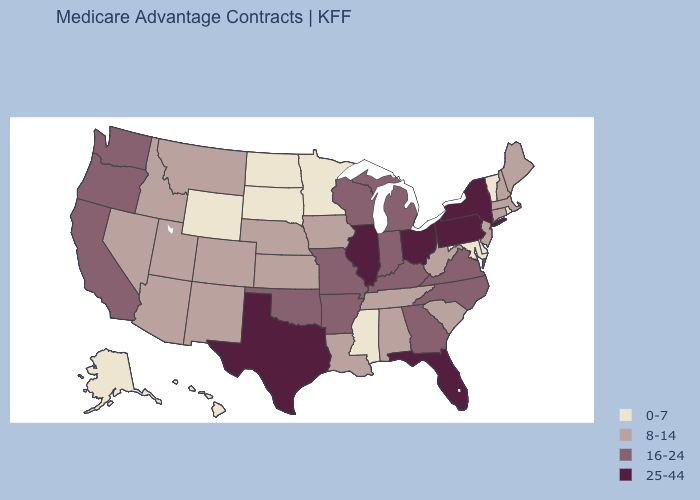What is the value of Mississippi?
Short answer required. 0-7. Which states have the lowest value in the USA?
Keep it brief. Alaska, Delaware, Hawaii, Maryland, Minnesota, Mississippi, North Dakota, Rhode Island, South Dakota, Vermont, Wyoming. What is the value of Montana?
Short answer required. 8-14. Name the states that have a value in the range 8-14?
Answer briefly. Alabama, Arizona, Colorado, Connecticut, Iowa, Idaho, Kansas, Louisiana, Massachusetts, Maine, Montana, Nebraska, New Hampshire, New Jersey, New Mexico, Nevada, South Carolina, Tennessee, Utah, West Virginia. Name the states that have a value in the range 16-24?
Answer briefly. Arkansas, California, Georgia, Indiana, Kentucky, Michigan, Missouri, North Carolina, Oklahoma, Oregon, Virginia, Washington, Wisconsin. Which states have the lowest value in the USA?
Be succinct. Alaska, Delaware, Hawaii, Maryland, Minnesota, Mississippi, North Dakota, Rhode Island, South Dakota, Vermont, Wyoming. What is the value of Missouri?
Short answer required. 16-24. Which states have the lowest value in the USA?
Concise answer only. Alaska, Delaware, Hawaii, Maryland, Minnesota, Mississippi, North Dakota, Rhode Island, South Dakota, Vermont, Wyoming. Name the states that have a value in the range 25-44?
Give a very brief answer. Florida, Illinois, New York, Ohio, Pennsylvania, Texas. How many symbols are there in the legend?
Quick response, please. 4. What is the highest value in the West ?
Quick response, please. 16-24. Among the states that border New York , which have the lowest value?
Be succinct. Vermont. What is the value of New Hampshire?
Be succinct. 8-14. Which states have the lowest value in the USA?
Be succinct. Alaska, Delaware, Hawaii, Maryland, Minnesota, Mississippi, North Dakota, Rhode Island, South Dakota, Vermont, Wyoming. Does Pennsylvania have the same value as New York?
Write a very short answer. Yes. 